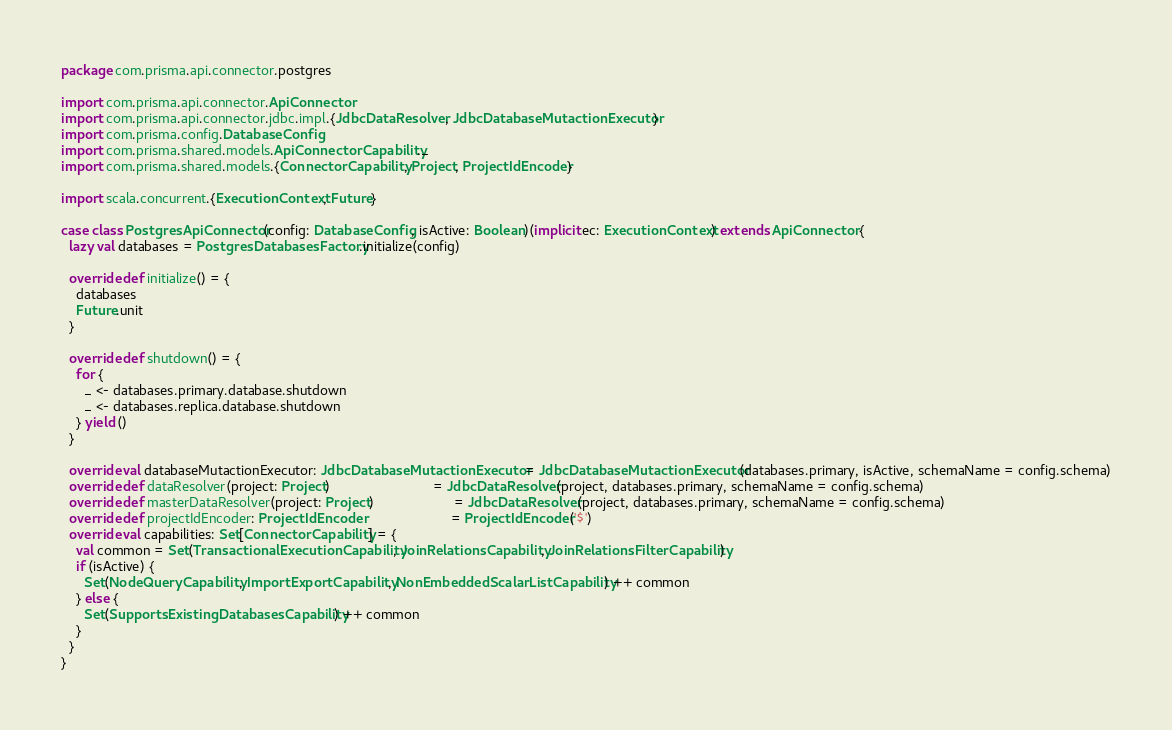Convert code to text. <code><loc_0><loc_0><loc_500><loc_500><_Scala_>package com.prisma.api.connector.postgres

import com.prisma.api.connector.ApiConnector
import com.prisma.api.connector.jdbc.impl.{JdbcDataResolver, JdbcDatabaseMutactionExecutor}
import com.prisma.config.DatabaseConfig
import com.prisma.shared.models.ApiConnectorCapability._
import com.prisma.shared.models.{ConnectorCapability, Project, ProjectIdEncoder}

import scala.concurrent.{ExecutionContext, Future}

case class PostgresApiConnector(config: DatabaseConfig, isActive: Boolean)(implicit ec: ExecutionContext) extends ApiConnector {
  lazy val databases = PostgresDatabasesFactory.initialize(config)

  override def initialize() = {
    databases
    Future.unit
  }

  override def shutdown() = {
    for {
      _ <- databases.primary.database.shutdown
      _ <- databases.replica.database.shutdown
    } yield ()
  }

  override val databaseMutactionExecutor: JdbcDatabaseMutactionExecutor = JdbcDatabaseMutactionExecutor(databases.primary, isActive, schemaName = config.schema)
  override def dataResolver(project: Project)                           = JdbcDataResolver(project, databases.primary, schemaName = config.schema)
  override def masterDataResolver(project: Project)                     = JdbcDataResolver(project, databases.primary, schemaName = config.schema)
  override def projectIdEncoder: ProjectIdEncoder                       = ProjectIdEncoder('$')
  override val capabilities: Set[ConnectorCapability] = {
    val common = Set(TransactionalExecutionCapability, JoinRelationsCapability, JoinRelationsFilterCapability)
    if (isActive) {
      Set(NodeQueryCapability, ImportExportCapability, NonEmbeddedScalarListCapability) ++ common
    } else {
      Set(SupportsExistingDatabasesCapability) ++ common
    }
  }
}
</code> 